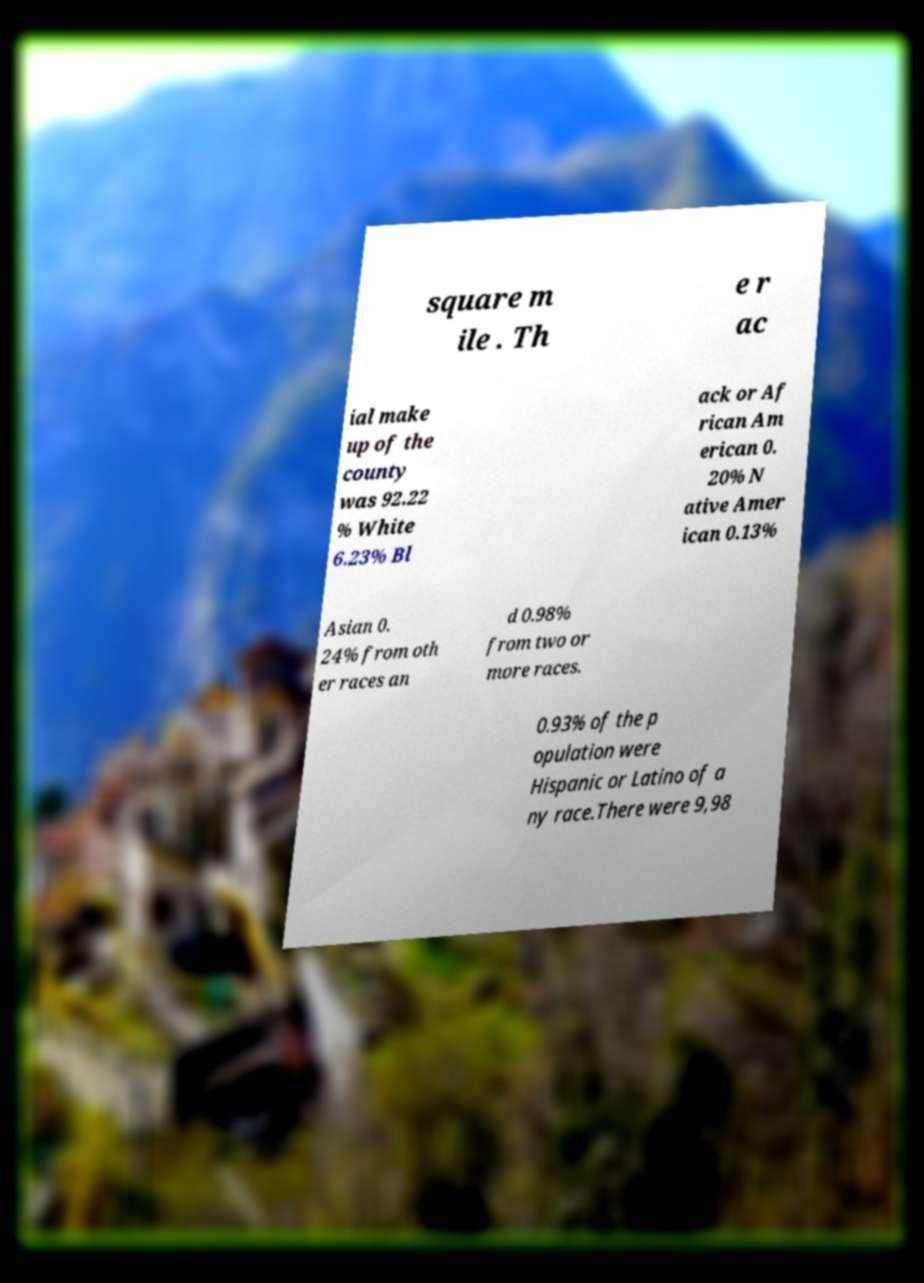Please identify and transcribe the text found in this image. square m ile . Th e r ac ial make up of the county was 92.22 % White 6.23% Bl ack or Af rican Am erican 0. 20% N ative Amer ican 0.13% Asian 0. 24% from oth er races an d 0.98% from two or more races. 0.93% of the p opulation were Hispanic or Latino of a ny race.There were 9,98 